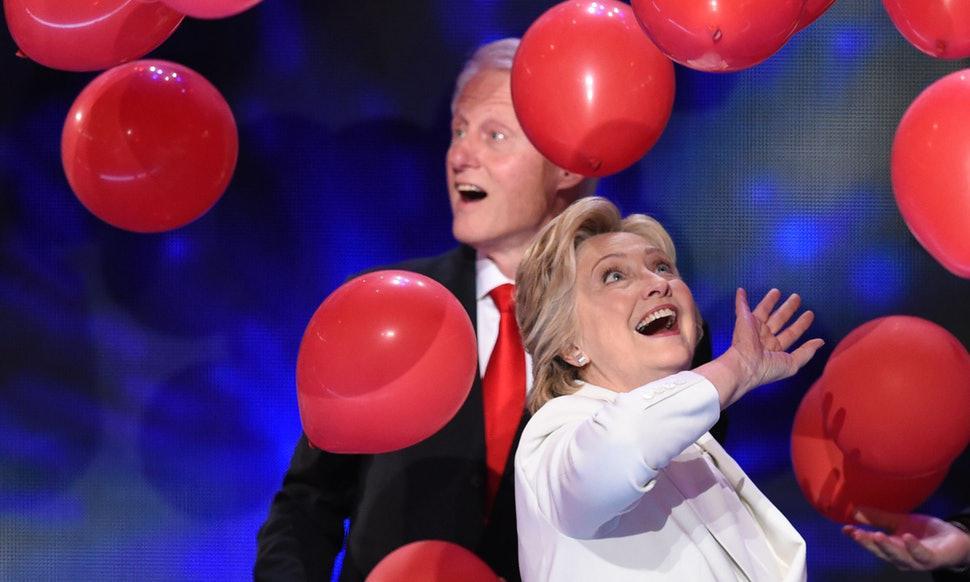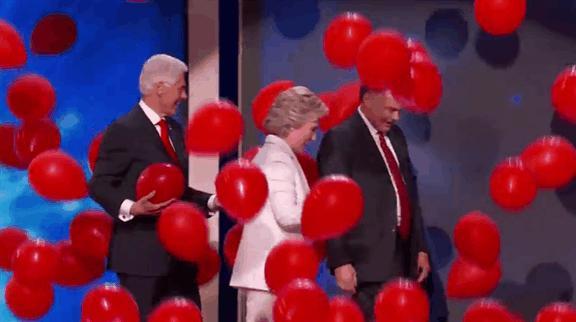The first image is the image on the left, the second image is the image on the right. Evaluate the accuracy of this statement regarding the images: "In at least one image the president his holding a single blue balloon with stars.". Is it true? Answer yes or no. No. The first image is the image on the left, the second image is the image on the right. For the images shown, is this caption "A white haired man is playing with red, white and blue balloons." true? Answer yes or no. No. 